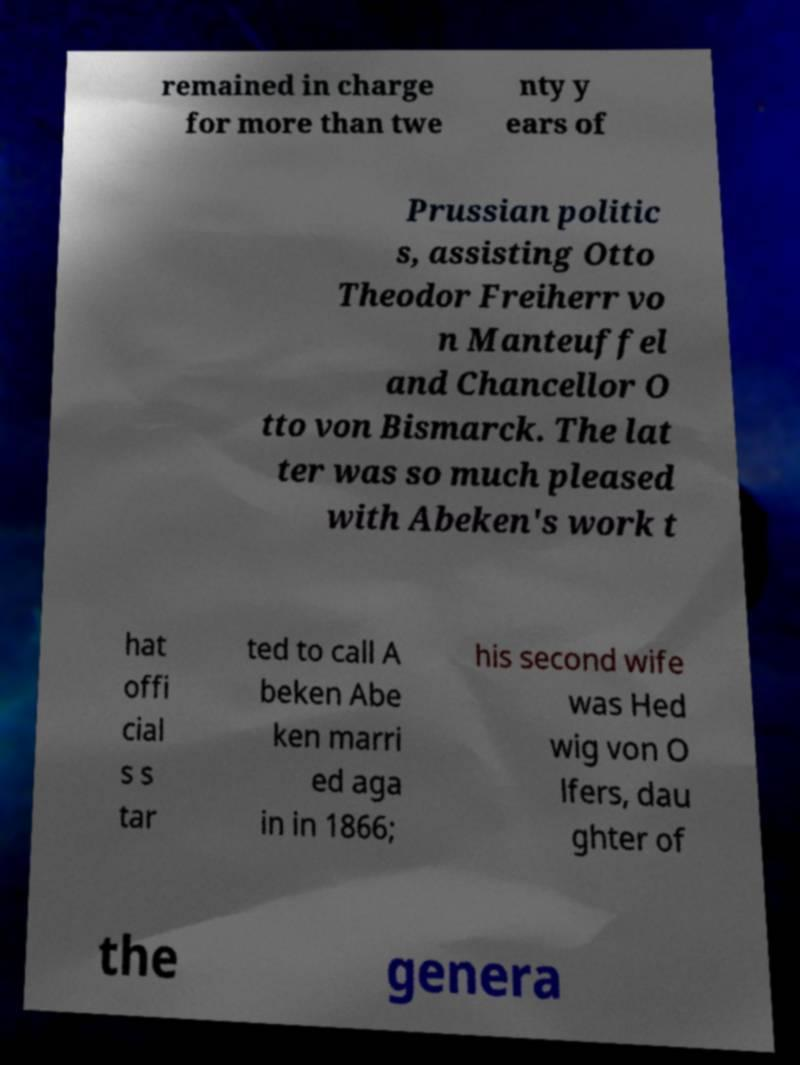Can you accurately transcribe the text from the provided image for me? remained in charge for more than twe nty y ears of Prussian politic s, assisting Otto Theodor Freiherr vo n Manteuffel and Chancellor O tto von Bismarck. The lat ter was so much pleased with Abeken's work t hat offi cial s s tar ted to call A beken Abe ken marri ed aga in in 1866; his second wife was Hed wig von O lfers, dau ghter of the genera 